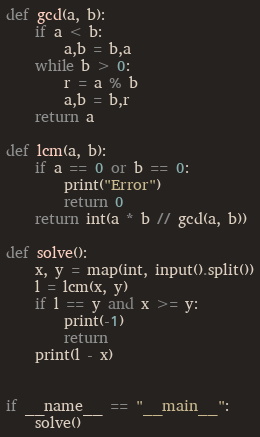<code> <loc_0><loc_0><loc_500><loc_500><_Python_>def gcd(a, b):
    if a < b:
        a,b = b,a
    while b > 0:
        r = a % b
        a,b = b,r
    return a

def lcm(a, b):
    if a == 0 or b == 0:
        print("Error")
        return 0
    return int(a * b // gcd(a, b))

def solve():
    x, y = map(int, input().split())
    l = lcm(x, y)
    if l == y and x >= y:
        print(-1)
        return
    print(l - x)


if __name__ == "__main__":
    solve()
</code> 